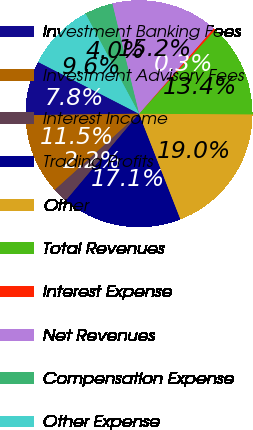<chart> <loc_0><loc_0><loc_500><loc_500><pie_chart><fcel>Investment Banking Fees<fcel>Investment Advisory Fees<fcel>Interest Income<fcel>Trading Profits<fcel>Other<fcel>Total Revenues<fcel>Interest Expense<fcel>Net Revenues<fcel>Compensation Expense<fcel>Other Expense<nl><fcel>7.76%<fcel>11.49%<fcel>2.16%<fcel>17.09%<fcel>18.96%<fcel>13.36%<fcel>0.29%<fcel>15.23%<fcel>4.03%<fcel>9.63%<nl></chart> 